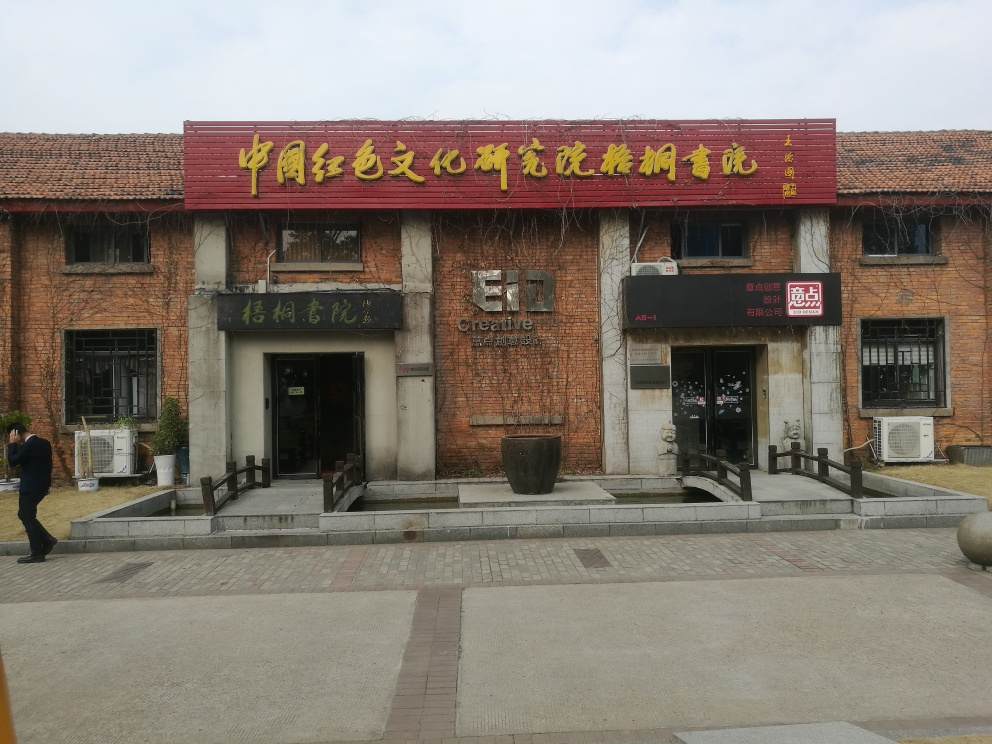Is there any distortion in the image?
 No 